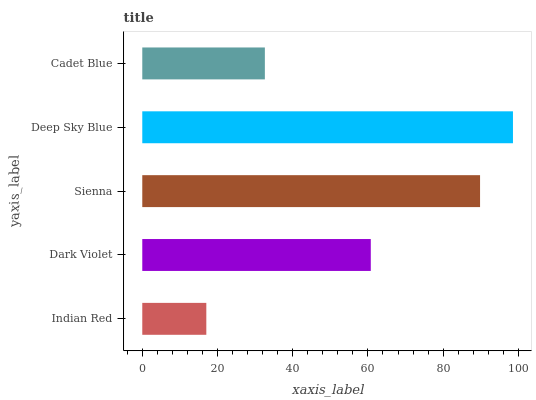Is Indian Red the minimum?
Answer yes or no. Yes. Is Deep Sky Blue the maximum?
Answer yes or no. Yes. Is Dark Violet the minimum?
Answer yes or no. No. Is Dark Violet the maximum?
Answer yes or no. No. Is Dark Violet greater than Indian Red?
Answer yes or no. Yes. Is Indian Red less than Dark Violet?
Answer yes or no. Yes. Is Indian Red greater than Dark Violet?
Answer yes or no. No. Is Dark Violet less than Indian Red?
Answer yes or no. No. Is Dark Violet the high median?
Answer yes or no. Yes. Is Dark Violet the low median?
Answer yes or no. Yes. Is Indian Red the high median?
Answer yes or no. No. Is Sienna the low median?
Answer yes or no. No. 